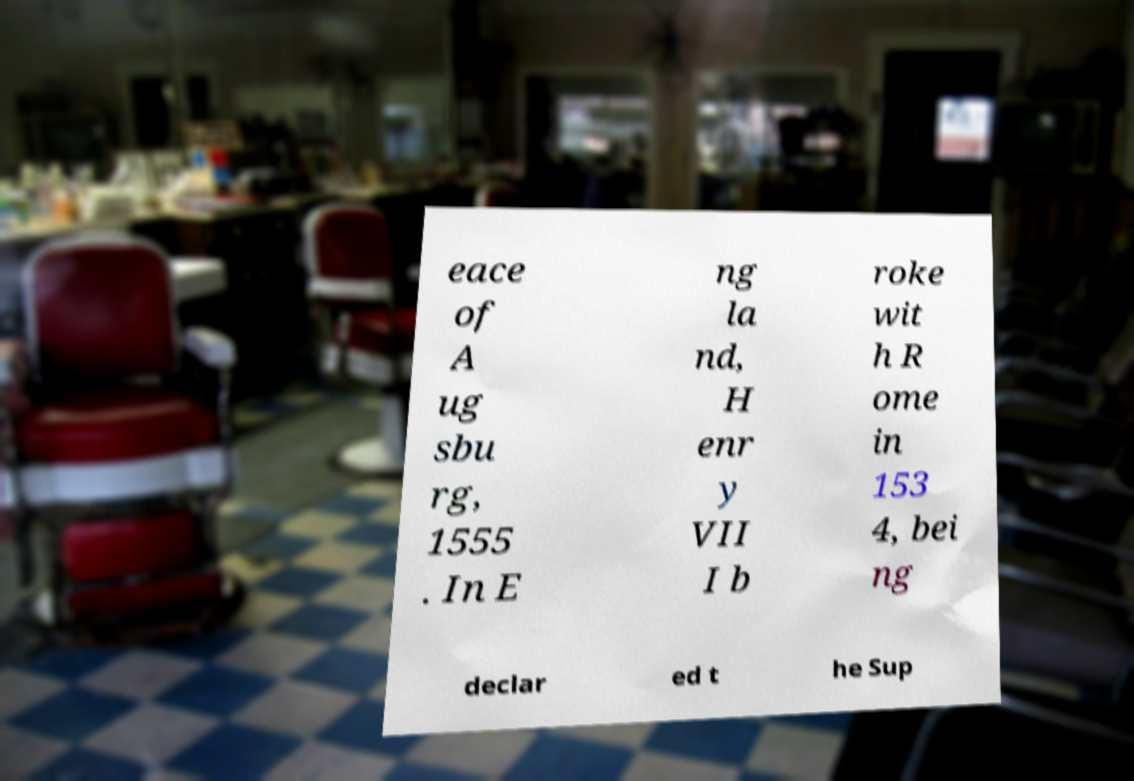Can you accurately transcribe the text from the provided image for me? eace of A ug sbu rg, 1555 . In E ng la nd, H enr y VII I b roke wit h R ome in 153 4, bei ng declar ed t he Sup 